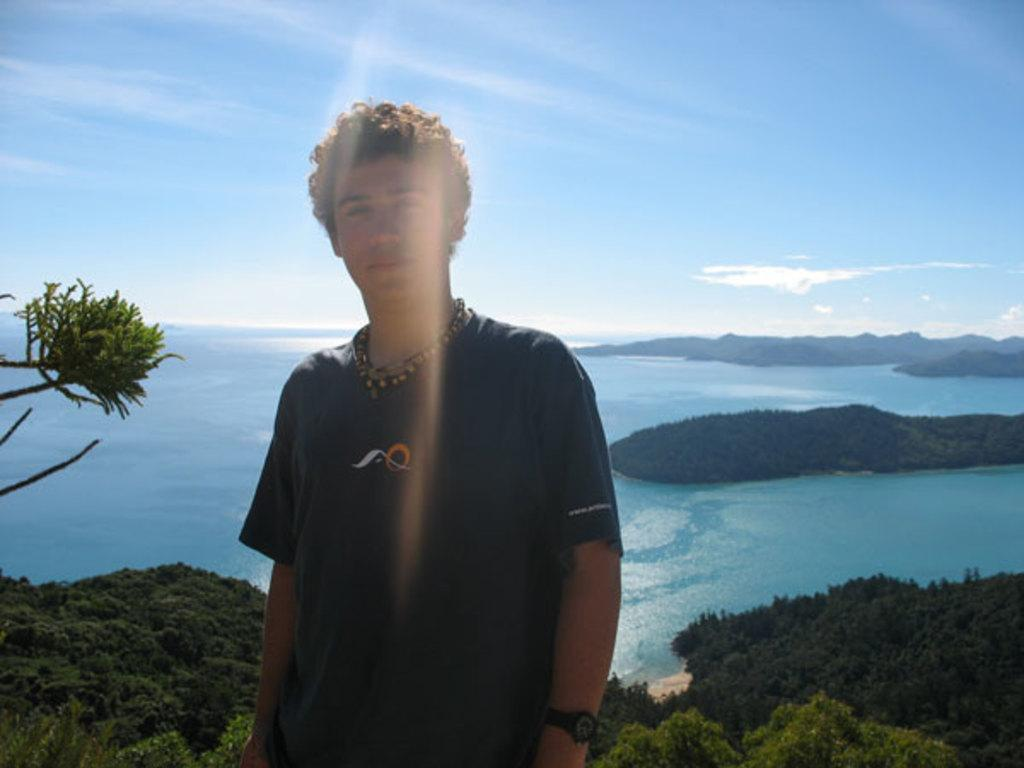Who is present in the image? There is a person in the image. What is the person wearing? The person is wearing a dress. What can be seen in the background of the image? There are plants, water, a tree, mountains, clouds, and the sky visible in the background of the image. What nation is the person from in the image? There is no information about the person's nationality in the image, so it cannot be determined. 